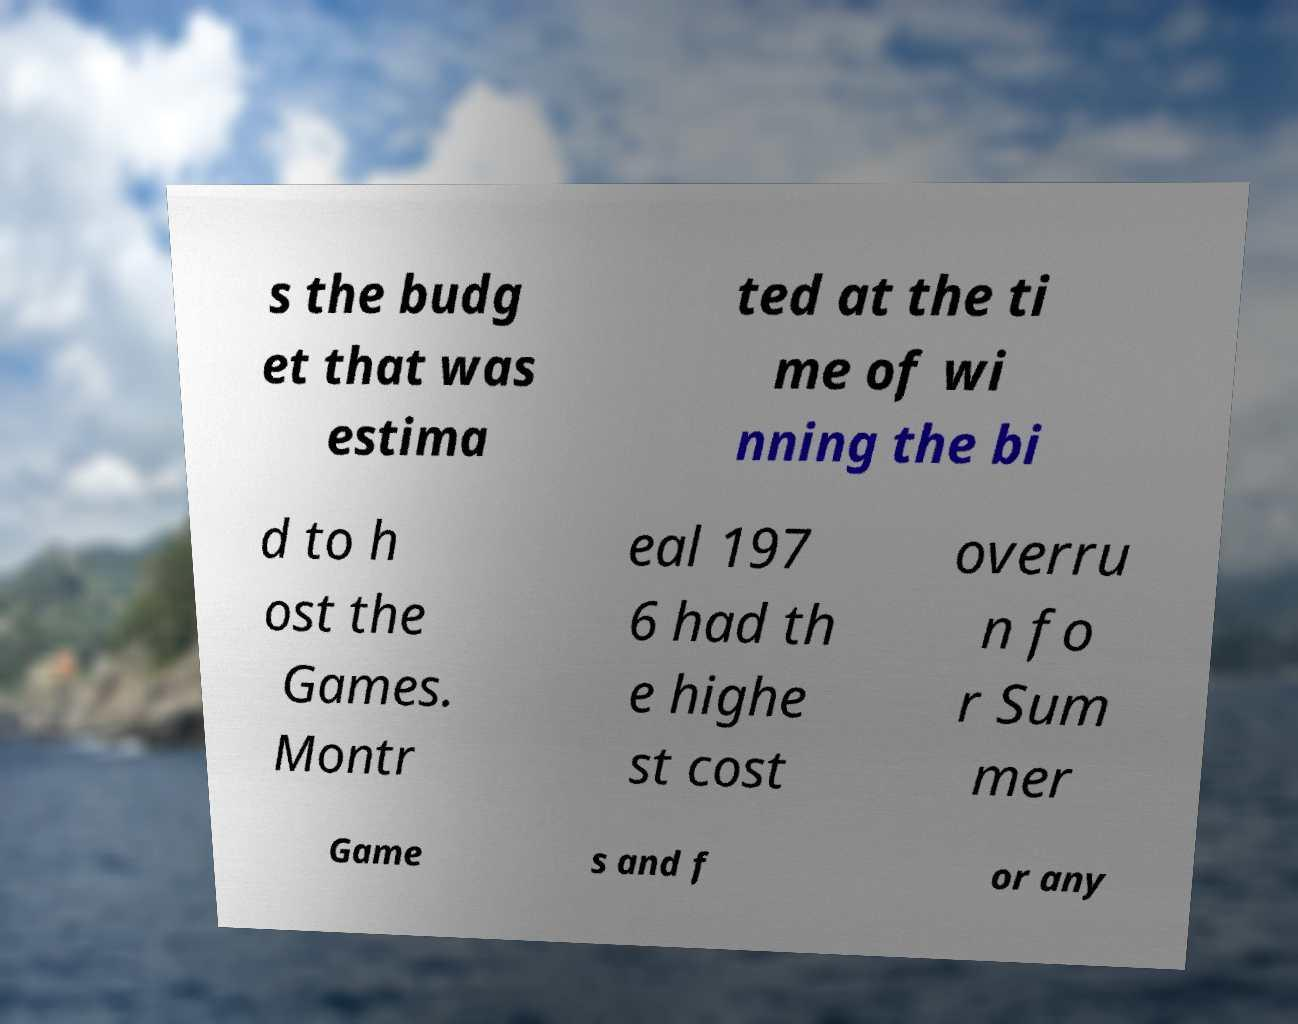Can you accurately transcribe the text from the provided image for me? s the budg et that was estima ted at the ti me of wi nning the bi d to h ost the Games. Montr eal 197 6 had th e highe st cost overru n fo r Sum mer Game s and f or any 